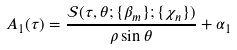Convert formula to latex. <formula><loc_0><loc_0><loc_500><loc_500>A _ { 1 } ( \tau ) = \frac { \mathcal { S } ( \tau , \theta ; \{ \beta _ { m } \} ; \{ \chi _ { n } \} ) } { \rho \sin { \theta } } + \alpha _ { 1 }</formula> 